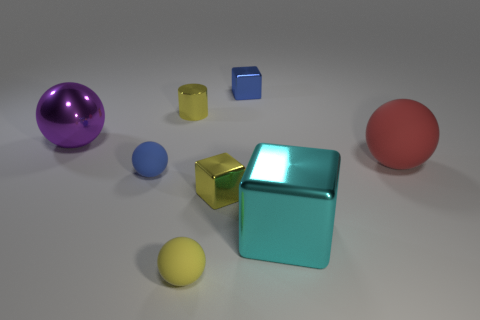Subtract all blue balls. Subtract all brown cubes. How many balls are left? 3 Subtract all green balls. How many cyan blocks are left? 1 Add 7 cyans. How many small objects exist? 0 Subtract all blue shiny cylinders. Subtract all purple objects. How many objects are left? 7 Add 3 large red things. How many large red things are left? 4 Add 4 cyan shiny cubes. How many cyan shiny cubes exist? 5 Add 2 yellow metallic cubes. How many objects exist? 10 Subtract all purple balls. How many balls are left? 3 Subtract all blue matte balls. How many balls are left? 3 Subtract 0 red blocks. How many objects are left? 8 